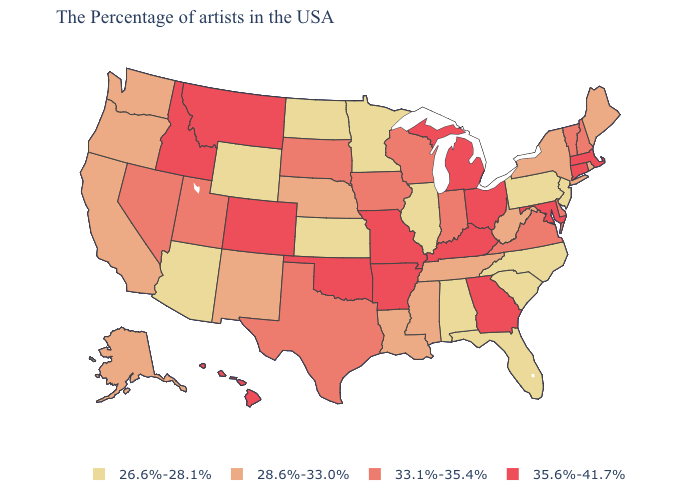What is the highest value in states that border North Dakota?
Concise answer only. 35.6%-41.7%. Name the states that have a value in the range 26.6%-28.1%?
Write a very short answer. New Jersey, Pennsylvania, North Carolina, South Carolina, Florida, Alabama, Illinois, Minnesota, Kansas, North Dakota, Wyoming, Arizona. Name the states that have a value in the range 28.6%-33.0%?
Short answer required. Maine, Rhode Island, New York, West Virginia, Tennessee, Mississippi, Louisiana, Nebraska, New Mexico, California, Washington, Oregon, Alaska. Does the map have missing data?
Quick response, please. No. Name the states that have a value in the range 35.6%-41.7%?
Write a very short answer. Massachusetts, Connecticut, Maryland, Ohio, Georgia, Michigan, Kentucky, Missouri, Arkansas, Oklahoma, Colorado, Montana, Idaho, Hawaii. Name the states that have a value in the range 28.6%-33.0%?
Be succinct. Maine, Rhode Island, New York, West Virginia, Tennessee, Mississippi, Louisiana, Nebraska, New Mexico, California, Washington, Oregon, Alaska. Name the states that have a value in the range 35.6%-41.7%?
Give a very brief answer. Massachusetts, Connecticut, Maryland, Ohio, Georgia, Michigan, Kentucky, Missouri, Arkansas, Oklahoma, Colorado, Montana, Idaho, Hawaii. Which states have the lowest value in the USA?
Short answer required. New Jersey, Pennsylvania, North Carolina, South Carolina, Florida, Alabama, Illinois, Minnesota, Kansas, North Dakota, Wyoming, Arizona. How many symbols are there in the legend?
Be succinct. 4. Does the map have missing data?
Write a very short answer. No. What is the value of Oklahoma?
Concise answer only. 35.6%-41.7%. What is the value of New Mexico?
Give a very brief answer. 28.6%-33.0%. What is the value of Iowa?
Give a very brief answer. 33.1%-35.4%. Does Colorado have a lower value than Utah?
Answer briefly. No. Name the states that have a value in the range 33.1%-35.4%?
Concise answer only. New Hampshire, Vermont, Delaware, Virginia, Indiana, Wisconsin, Iowa, Texas, South Dakota, Utah, Nevada. 